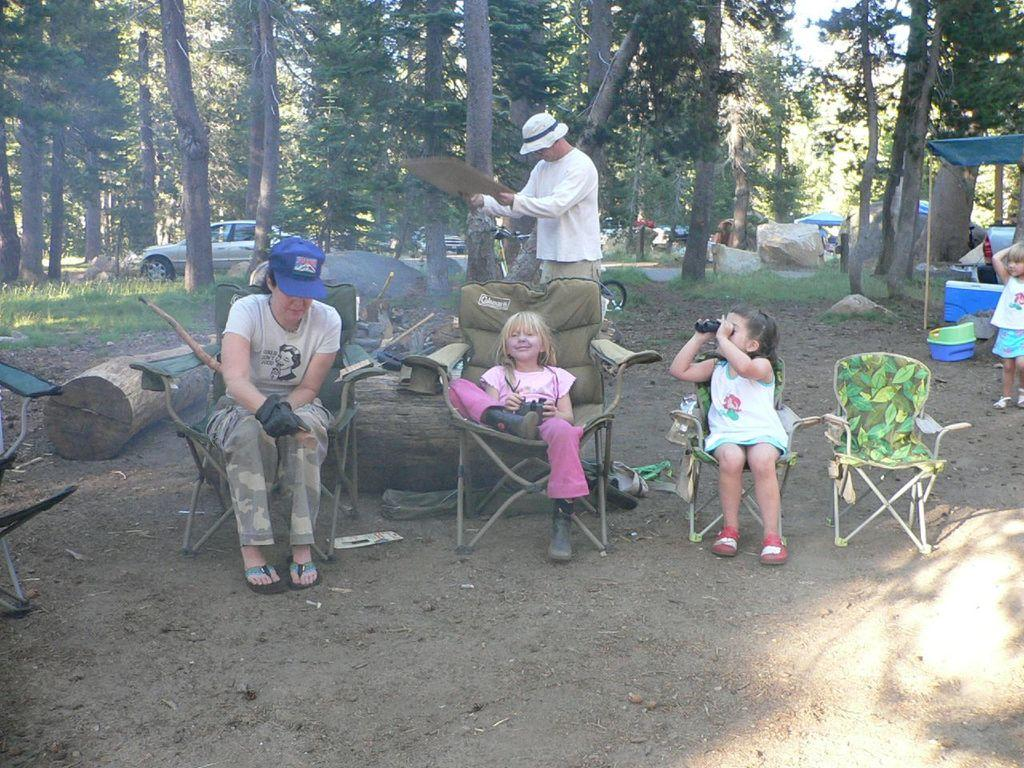Who is present in the image? There is a woman, two children, a man, and a girl in the image. What are the children doing in the image? The children are seated in the image. What is the man doing in the image? The man is standing in the image. What is the girl doing in the image? The girl is standing in the image. What furniture is visible in the image? The chairs are visible in the image. What can be seen in the background of the image? Trees are present around the scene. What vehicle is parked in the image? A car is parked in the image. What type of kitty is the doctor holding in the image? There is no kitty or doctor present in the image. How many legs does the woman have in the image? The woman has two legs in the image, as is typical for humans. 